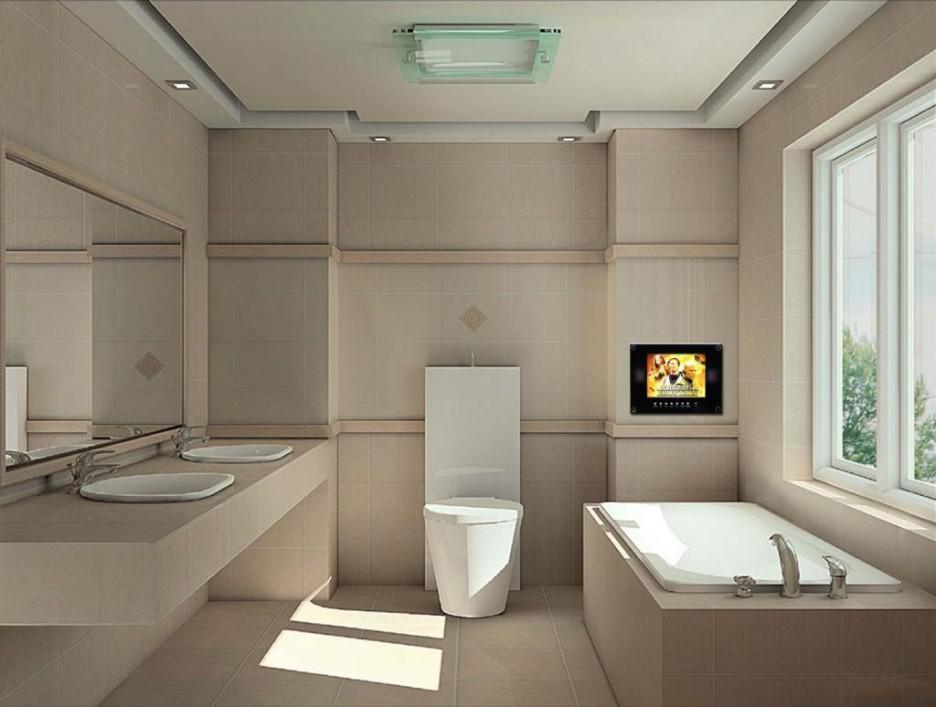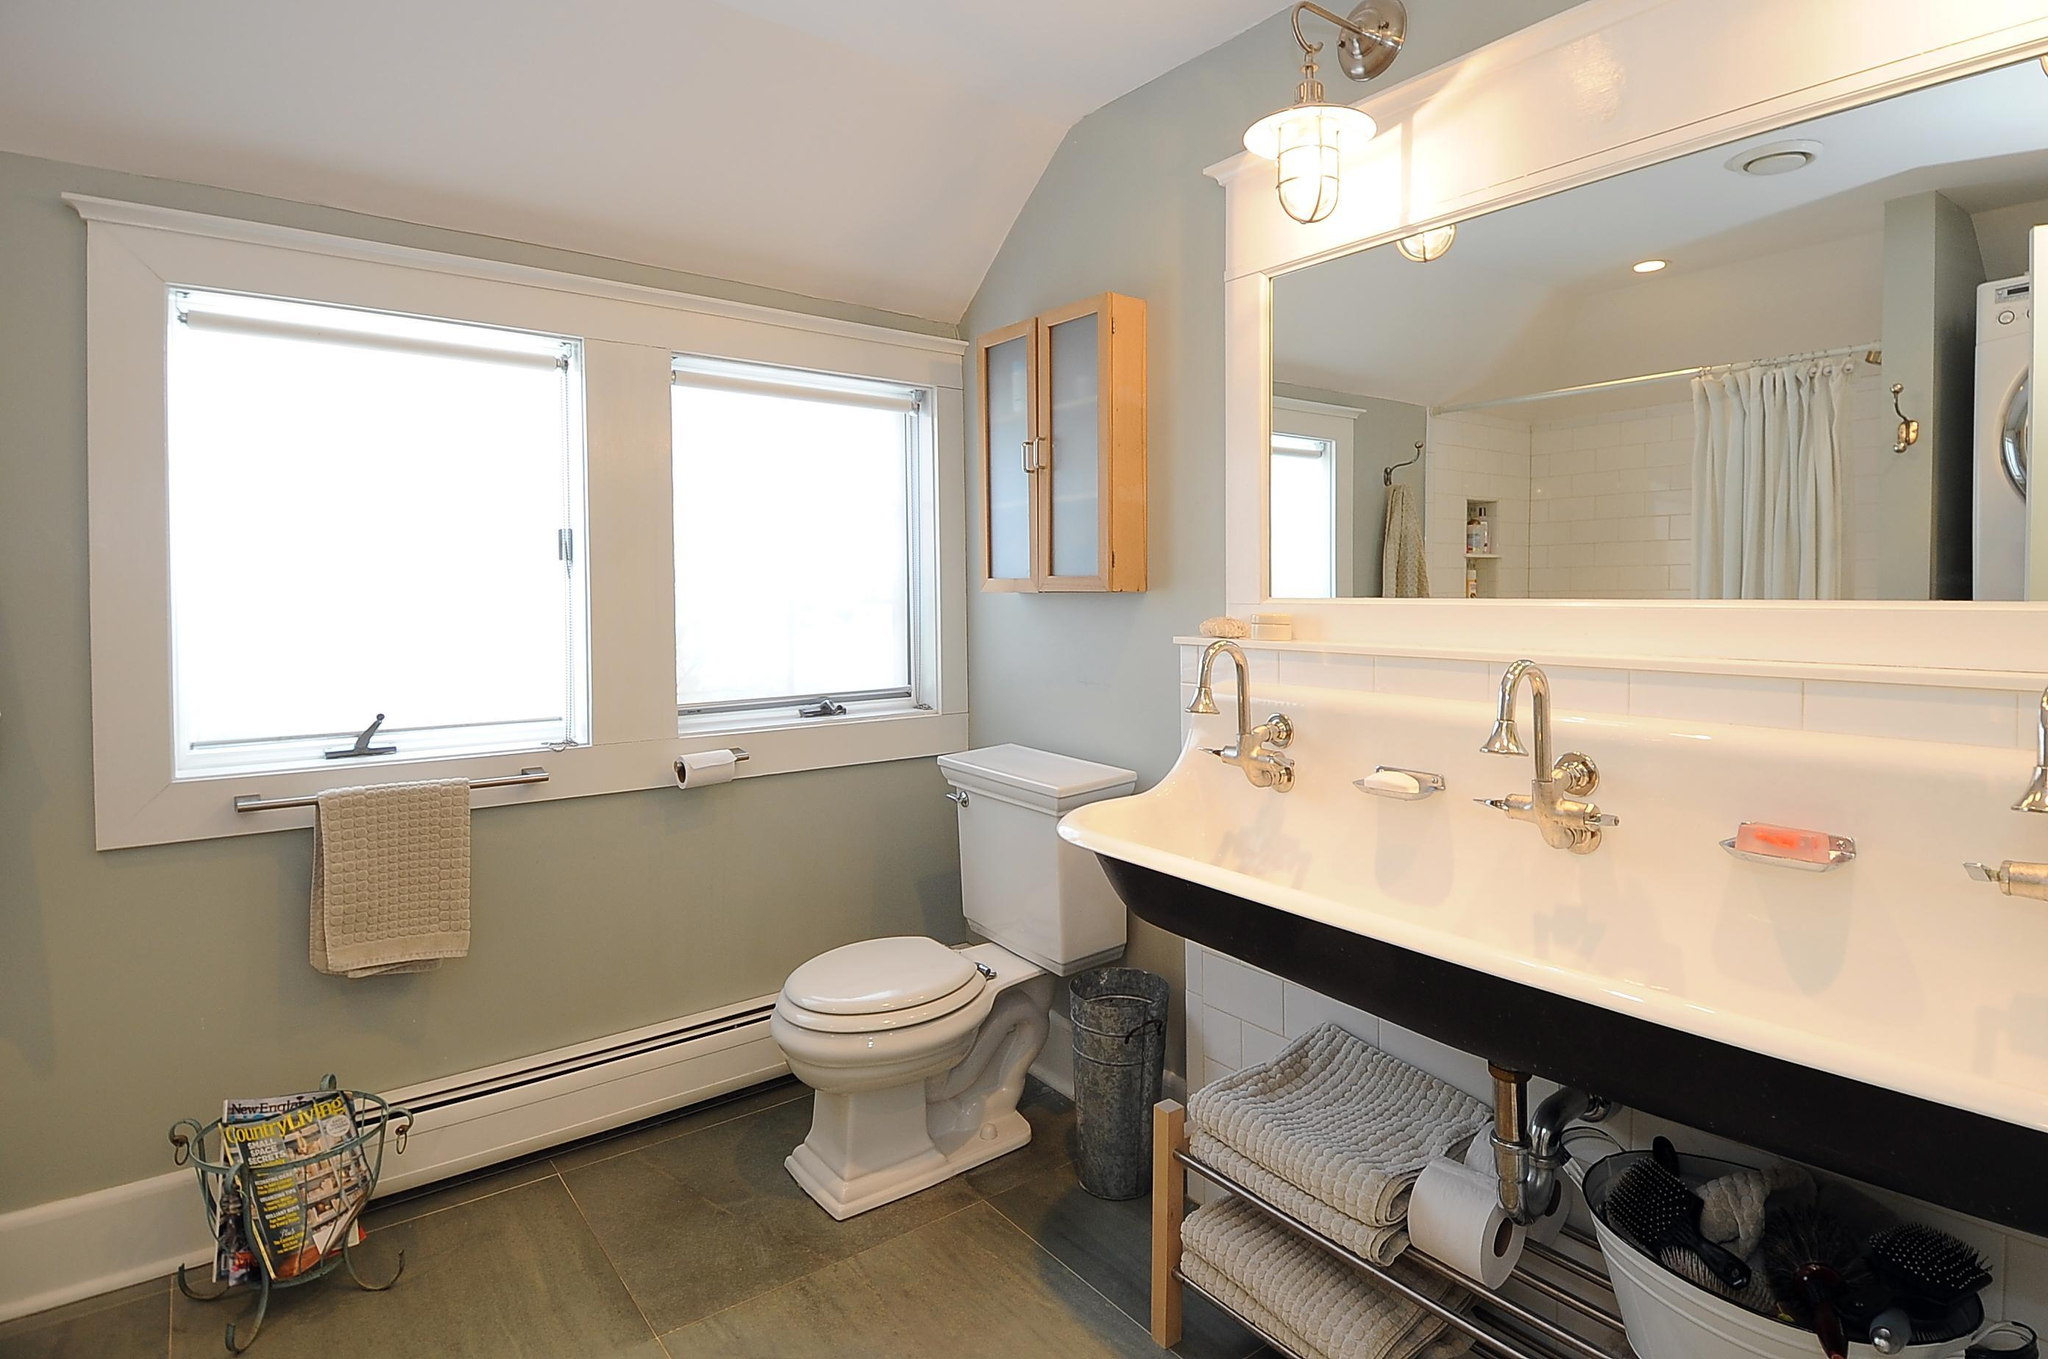The first image is the image on the left, the second image is the image on the right. Analyze the images presented: Is the assertion "There are four sink faucets" valid? Answer yes or no. Yes. The first image is the image on the left, the second image is the image on the right. Analyze the images presented: Is the assertion "One image shows a seamless mirror over an undivided white 'trough' sink with multiple spouts over it, which has a white toilet with a tank behind it." valid? Answer yes or no. Yes. 